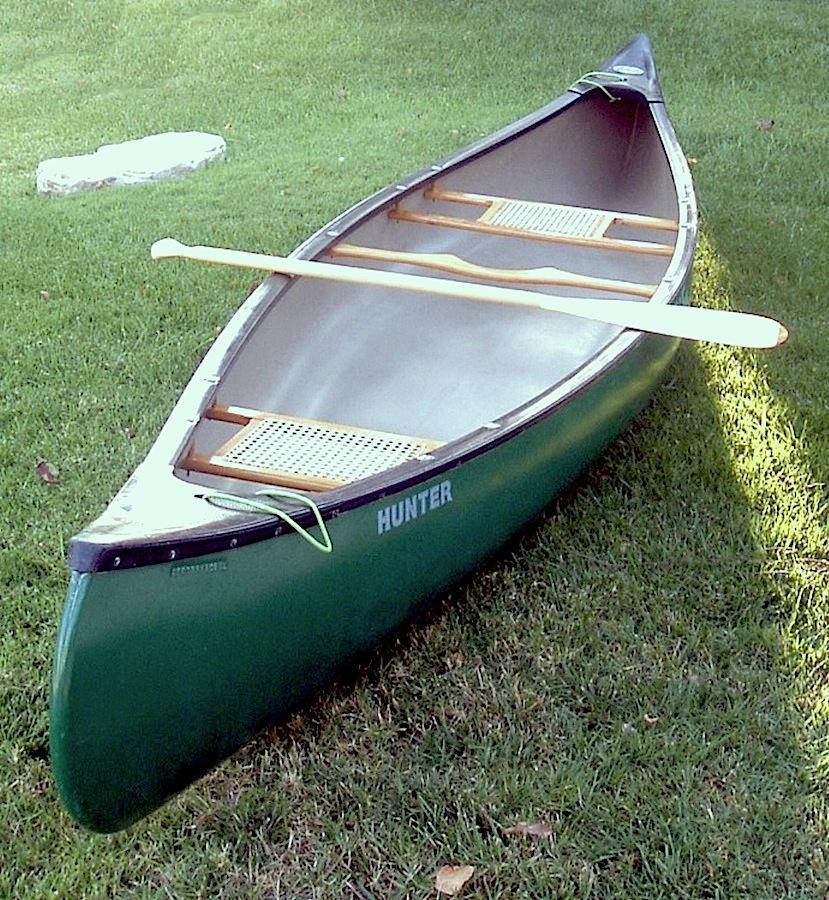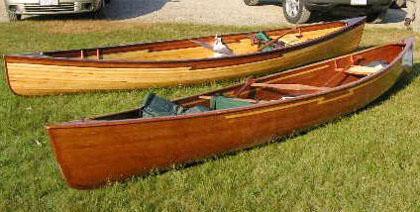The first image is the image on the left, the second image is the image on the right. Assess this claim about the two images: "One image shows side-by-side woodgrain canoes on land, and the other image includes a green canoe.". Correct or not? Answer yes or no. Yes. The first image is the image on the left, the second image is the image on the right. Considering the images on both sides, is "The left image contains two canoes laying next to each other in the grass." valid? Answer yes or no. No. 